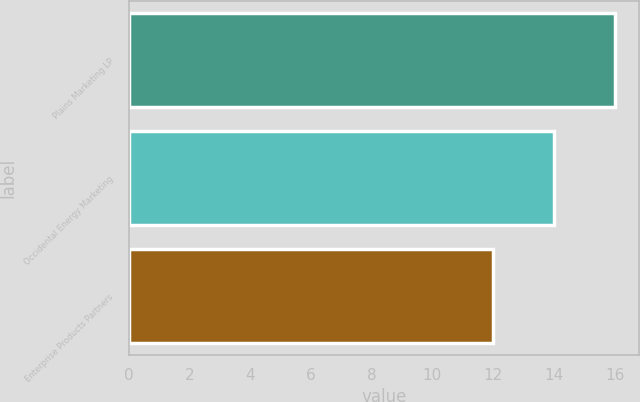Convert chart to OTSL. <chart><loc_0><loc_0><loc_500><loc_500><bar_chart><fcel>Plains Marketing LP<fcel>Occidental Energy Marketing<fcel>Enterprise Products Partners<nl><fcel>16<fcel>14<fcel>12<nl></chart> 